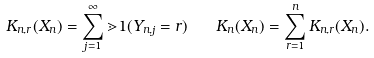Convert formula to latex. <formula><loc_0><loc_0><loc_500><loc_500>K _ { n , r } ( X _ { n } ) = \sum _ { j = 1 } ^ { \infty } \mathbb { m } { 1 } ( Y _ { n , j } = r ) \quad K _ { n } ( X _ { n } ) = \sum _ { r = 1 } ^ { n } K _ { n , r } ( X _ { n } ) .</formula> 